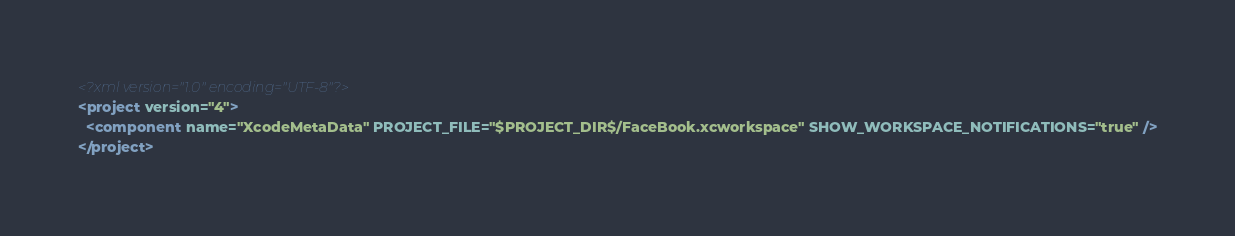<code> <loc_0><loc_0><loc_500><loc_500><_XML_><?xml version="1.0" encoding="UTF-8"?>
<project version="4">
  <component name="XcodeMetaData" PROJECT_FILE="$PROJECT_DIR$/FaceBook.xcworkspace" SHOW_WORKSPACE_NOTIFICATIONS="true" />
</project></code> 